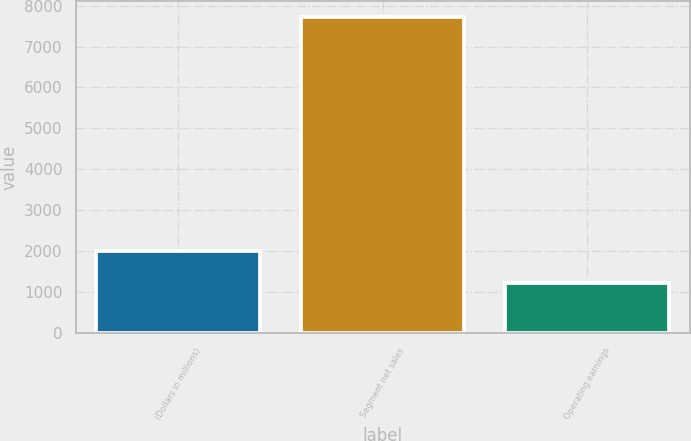<chart> <loc_0><loc_0><loc_500><loc_500><bar_chart><fcel>(Dollars in millions)<fcel>Segment net sales<fcel>Operating earnings<nl><fcel>2007<fcel>7729<fcel>1213<nl></chart> 